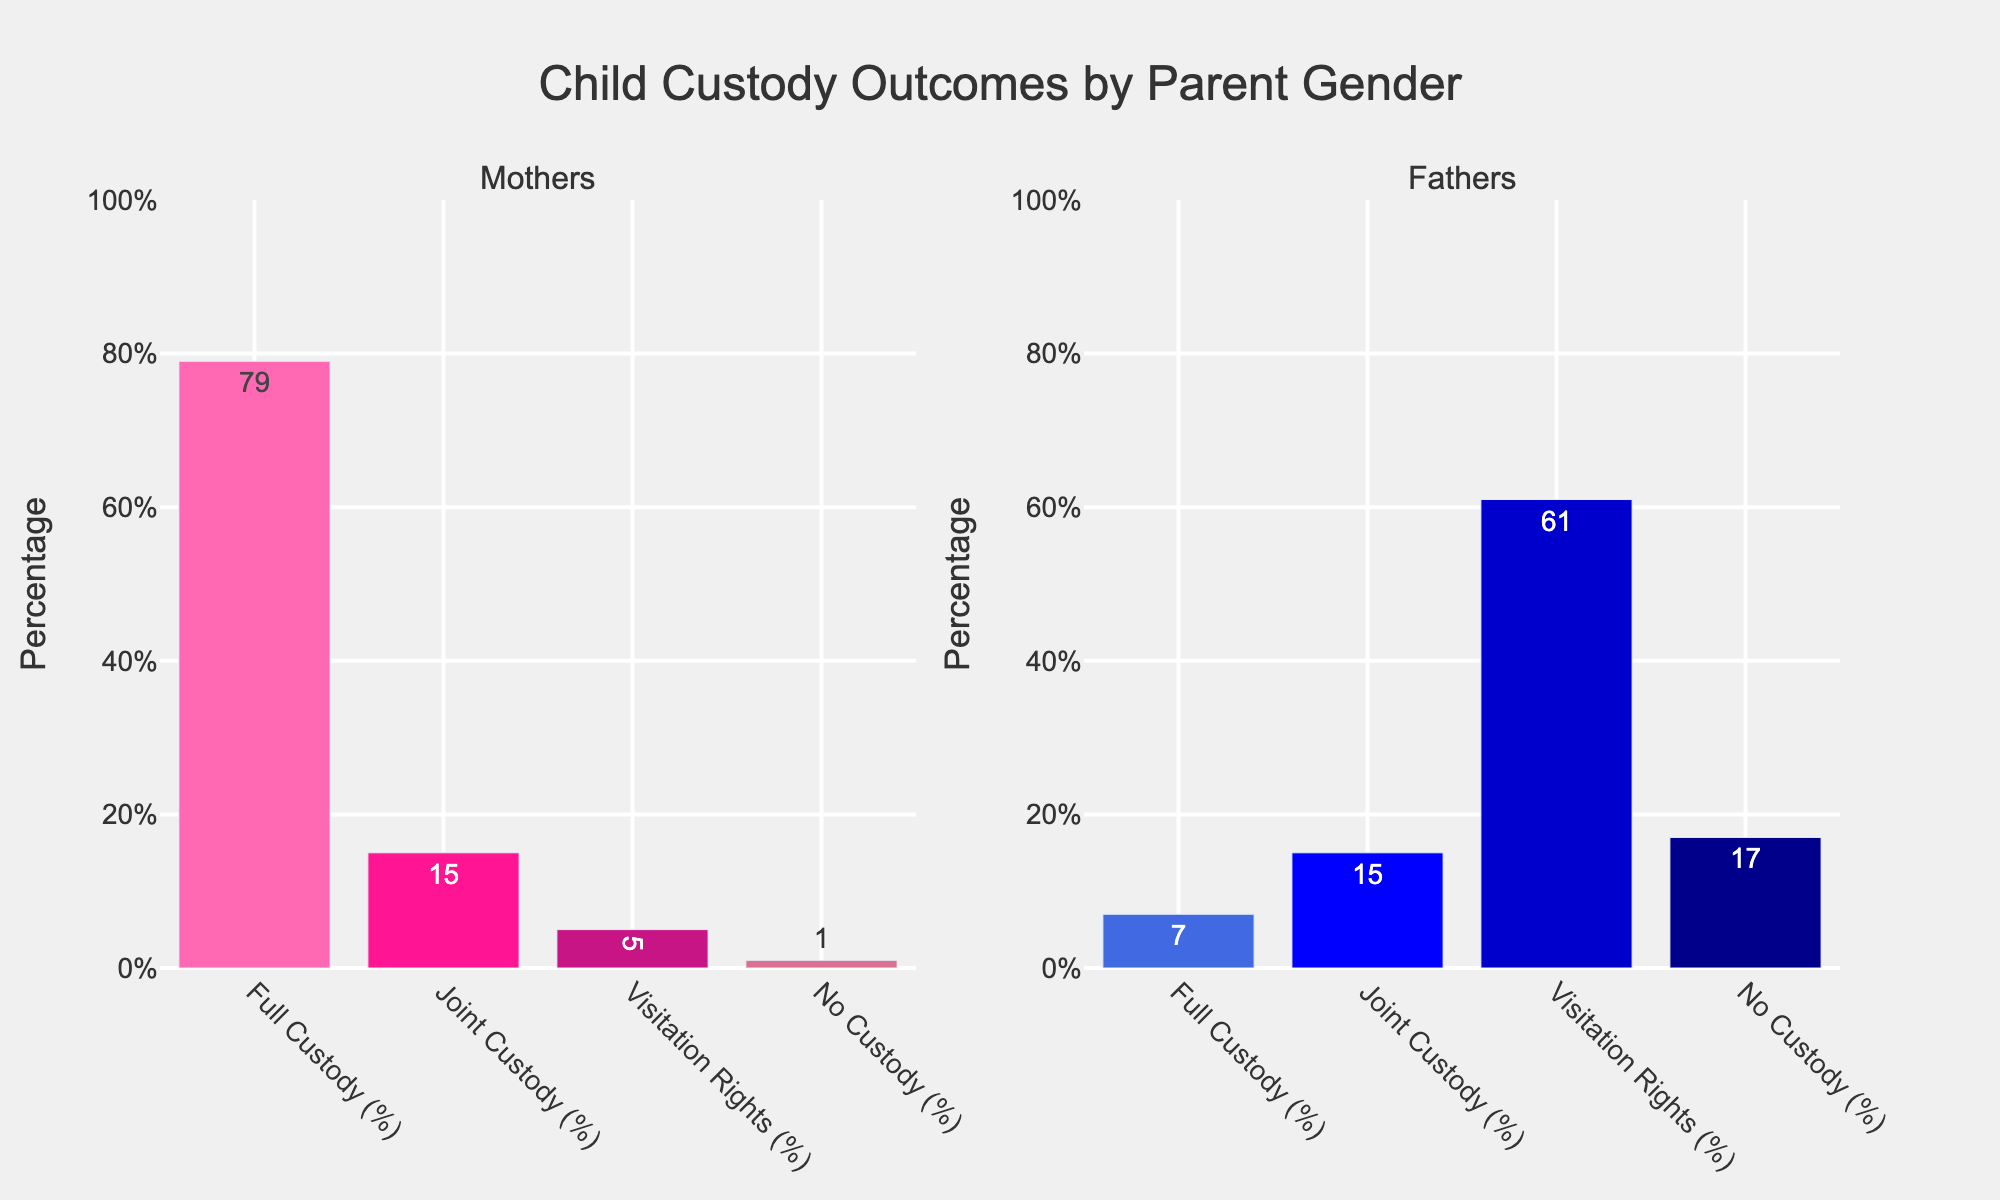Which parent gender has the highest percentage of full custody? By examining the bar heights, the bar for mothers is much taller in the full custody category compared to fathers. Therefore, mothers have the highest percentage.
Answer: Mothers What is the total percentage of fathers who have either full custody or visitation rights? Fathers have 7% full custody and 61% visitation rights. Adding these percentages gives 7 + 61 = 68%.
Answer: 68% Comparing mothers and fathers, which parent gender has a higher percentage of no custody? By comparing the heights of the bars in the no custody category, fathers have a higher no custody percentage at 17%, while mothers have only 1%.
Answer: Fathers What is the difference in joint custody percentages between mothers and fathers? Both mothers and fathers have the same percentage (15%) for joint custody. Therefore, the difference is 0%.
Answer: 0% What color is used to represent the category of visitation rights for fathers? Observing the colors used in the father's chart, the bar for visitation rights is in a dark blue shade.
Answer: Dark blue What is the combined percentage of mothers who have either full or joint custody? For mothers, add the percentages of full custody (79%) and joint custody (15%): 79 + 15 = 94%.
Answer: 94% Which custody outcome has the smallest percentage for fathers? Looking at the bar chart for fathers, the smallest bar corresponds to full custody which is 7%.
Answer: Full custody How much higher is the visitation rights percentage for fathers compared to mothers? Fathers have 61%, while mothers have 5% for visitation rights. Subtract to find the difference: 61 - 5 = 56%.
Answer: 56% What is the average percentage of custody outcomes for mothers across all categories? Calculate the average of 79% (full custody), 15% (joint custody), 5% (visitation rights), and 1% (no custody): (79 + 15 + 5 + 1) / 4 = 100 / 4 = 25%.
Answer: 25% 